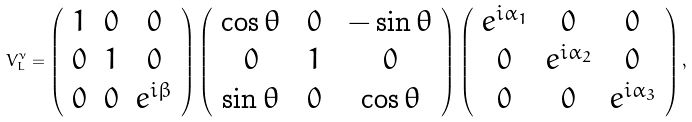Convert formula to latex. <formula><loc_0><loc_0><loc_500><loc_500>V _ { L } ^ { \nu } = \left ( \begin{array} { c c c } 1 & 0 & 0 \\ 0 & 1 & 0 \\ 0 & 0 & e ^ { i \beta } \end{array} \right ) \left ( \begin{array} { c c c } \cos \theta & \ 0 & \ - \sin \theta \\ 0 & \ 1 & \ 0 \\ \sin \theta & \ 0 & \ \cos \theta \end{array} \right ) \left ( \begin{array} { c c c } e ^ { i \alpha _ { 1 } } & 0 & 0 \\ 0 & e ^ { i \alpha _ { 2 } } & 0 \\ 0 & 0 & e ^ { i \alpha _ { 3 } } \end{array} \right ) ,</formula> 